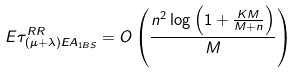Convert formula to latex. <formula><loc_0><loc_0><loc_500><loc_500>E \tau ^ { R R } _ { ( \mu + \lambda ) E A _ { 1 B S } } = O \left ( \frac { n ^ { 2 } \log \left ( 1 + \frac { K M } { M + n } \right ) } { M } \right )</formula> 